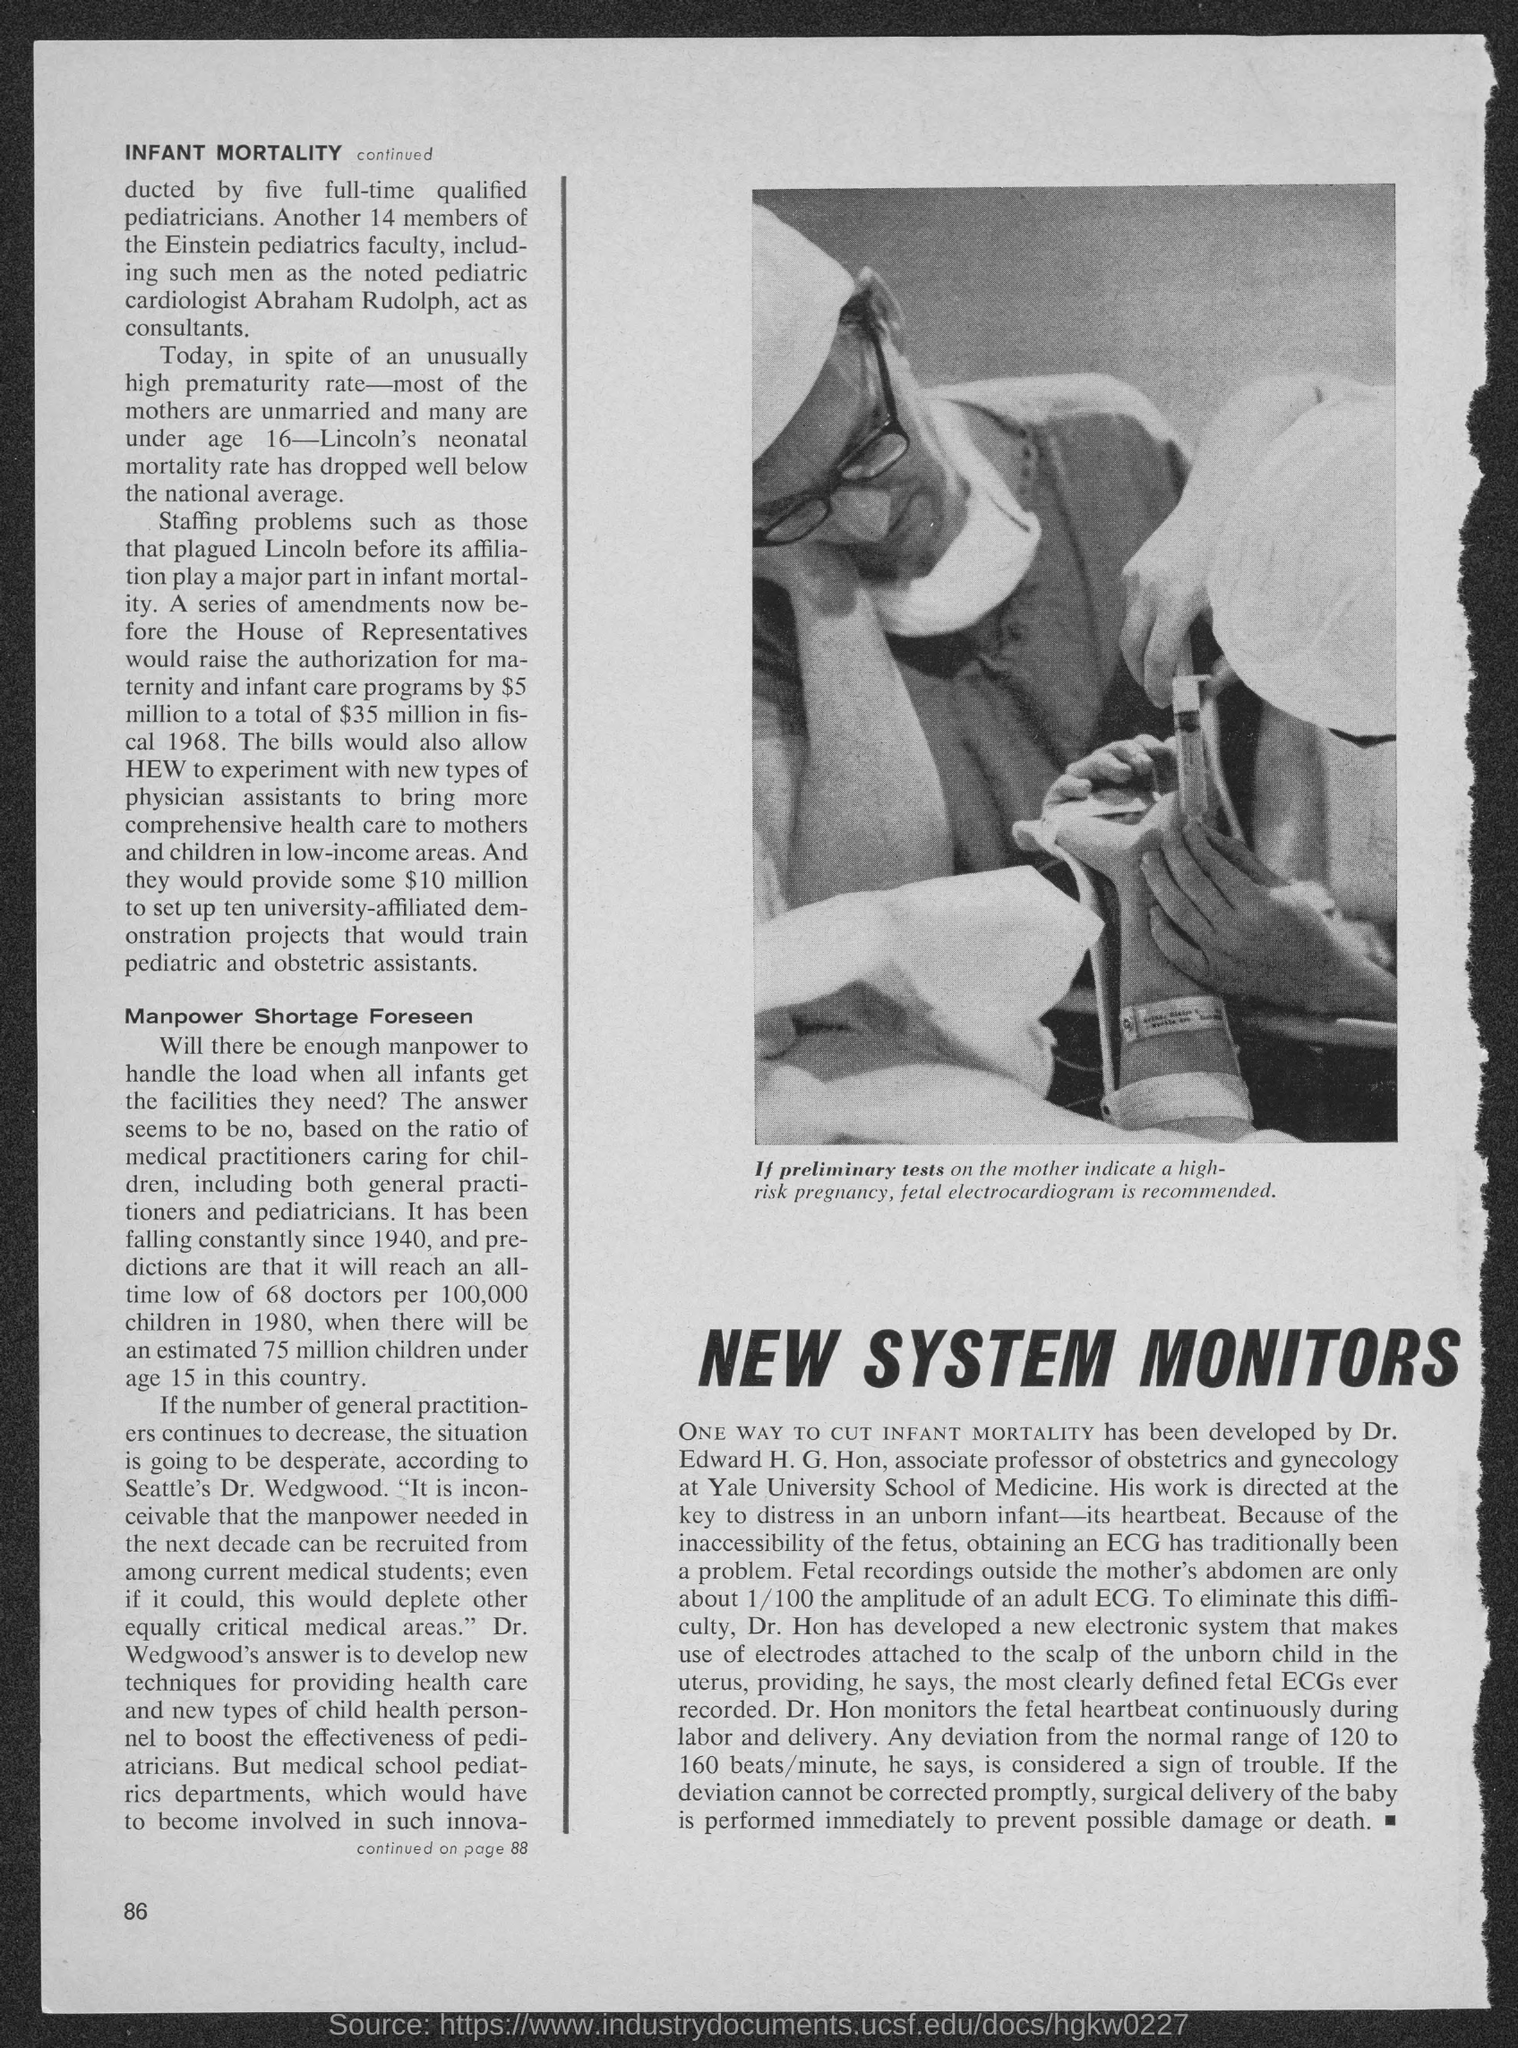If tests on mother indicate a high-risk pregnancy, what is recommended?
Ensure brevity in your answer.  Fetal Electrocardiogram. Who has developed a way to cut infant mortality?
Give a very brief answer. Dr. Edward H. G. Hon. 